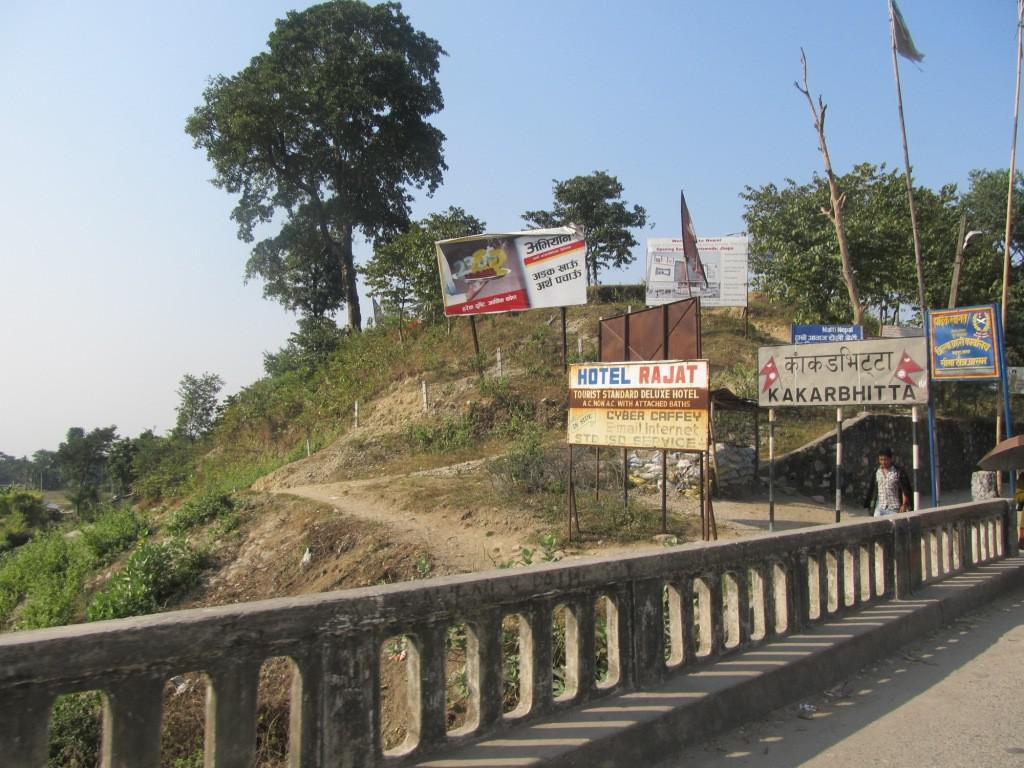<image>
Render a clear and concise summary of the photo. A sign for a hotel stands on a hill side next to a road. 